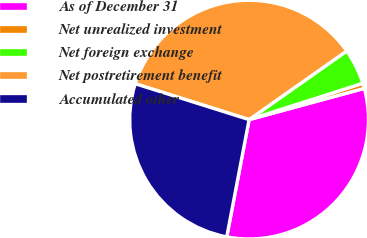Convert chart. <chart><loc_0><loc_0><loc_500><loc_500><pie_chart><fcel>As of December 31<fcel>Net unrealized investment<fcel>Net foreign exchange<fcel>Net postretirement benefit<fcel>Accumulated other<nl><fcel>32.22%<fcel>0.71%<fcel>4.83%<fcel>35.39%<fcel>26.86%<nl></chart> 